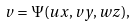Convert formula to latex. <formula><loc_0><loc_0><loc_500><loc_500>v = \Psi ( u x , v y , w z ) ,</formula> 